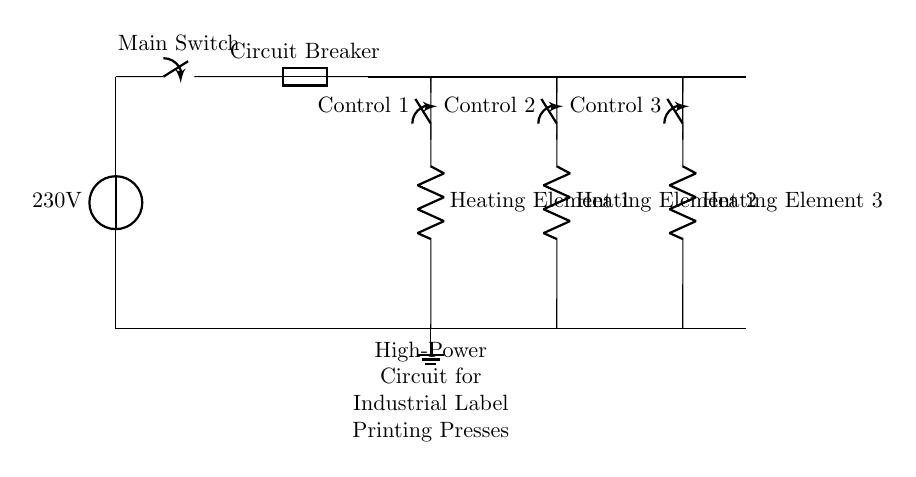What is the voltage of this circuit? The voltage source at the beginning of the circuit is labeled as 230V, indicating the potential difference provided to the circuit.
Answer: 230V What is the purpose of the main switch? The main switch is used to control the power flow in the circuit; it can disconnect or connect the circuit to the power supply.
Answer: To control power How many heating elements are included in this circuit? According to the circuit diagram, there are three distinct heating elements labeled in the circuit.
Answer: Three What is the function of the circuit breaker? The circuit breaker serves as a protective device that interrupts the circuit if the current exceeds a certain threshold, preventing overload.
Answer: Protection If all heating elements are activated, how does that affect the circuit? Activating all heating elements will increase the total current draw from the power source, requiring careful consideration for wire gauge and circuit protection to avoid overheating or tripping the breaker.
Answer: Increases current draw What type of switch is used for each heating element? Each heating element has a control switch that allows individual operation, facilitating control based on printing requirements and efficiency.
Answer: Control switch What is the ground connection used for in this circuit? The ground connection serves as a safety feature, providing a path for electrical current to safely dissipate into the earth in case of a fault, helping to prevent shock hazards.
Answer: Safety 